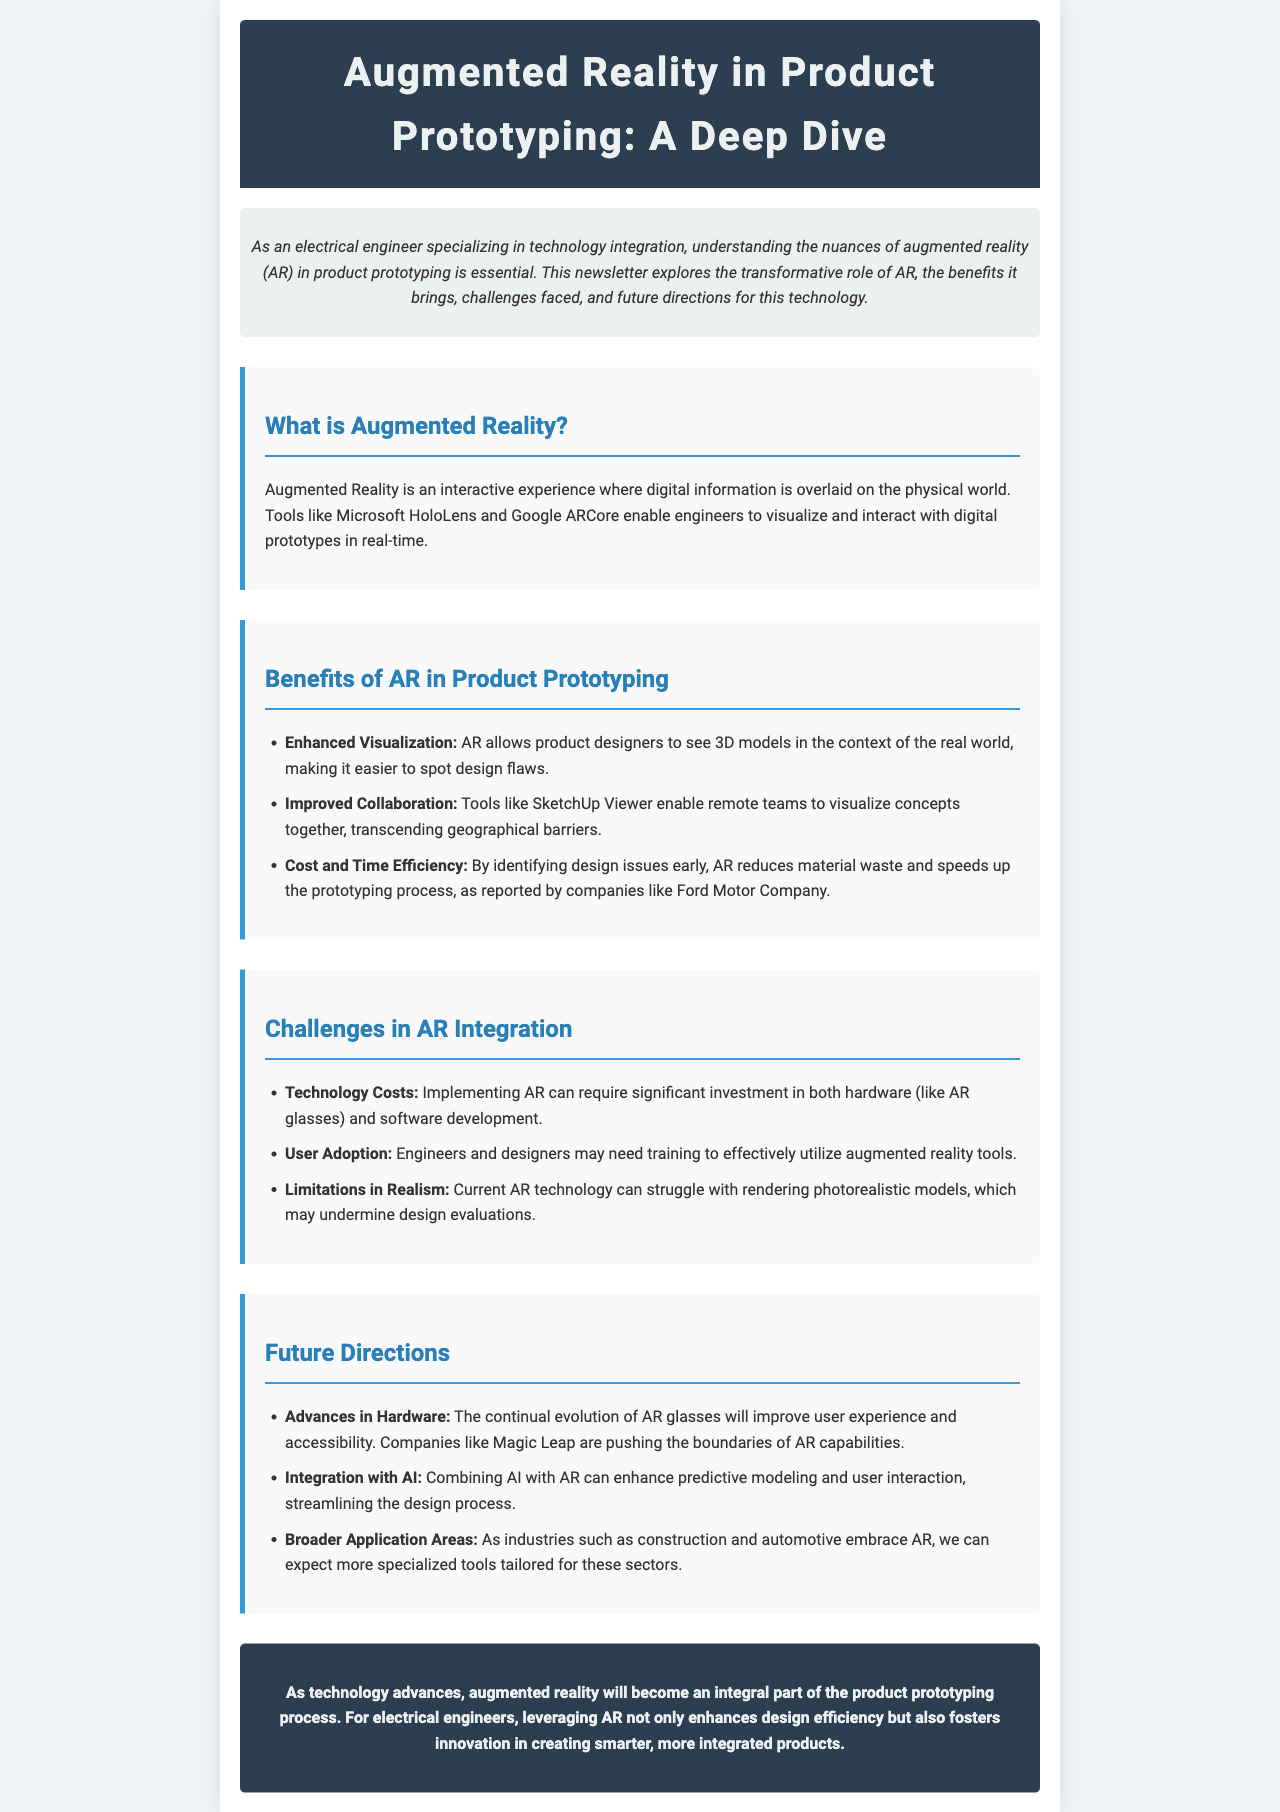What is Augmented Reality? Augmented Reality is defined in the document as an interactive experience where digital information is overlaid on the physical world.
Answer: An interactive experience What tools are mentioned for AR visualization? The document lists specific tools used for AR visualization, namely Microsoft HoloLens and Google ARCore.
Answer: Microsoft HoloLens and Google ARCore What is one benefit of AR in product prototyping? The benefits section highlights enhanced visualization as one of the key advantages of using AR in product prototyping.
Answer: Enhanced Visualization What is a challenge mentioned regarding AR integration? The document states technology costs as one of the main challenges faced when integrating AR.
Answer: Technology Costs Which company is cited for reducing material waste with AR? Ford Motor Company is mentioned in the document as a company that reported reduced material waste due to early identification of design issues through AR.
Answer: Ford Motor Company What future advancement is expected in AR hardware? The document anticipates continual evolution of AR glasses to improve user experience and accessibility.
Answer: AR glasses How can AI improve AR? The document suggests that integrating AI with AR can enhance predictive modeling and user interaction.
Answer: Enhance predictive modeling and user interaction What is the overall conclusion about AR in product prototyping? The conclusion of the document states that AR will become integral to the product prototyping process for electrical engineers.
Answer: Integral part of the product prototyping process 